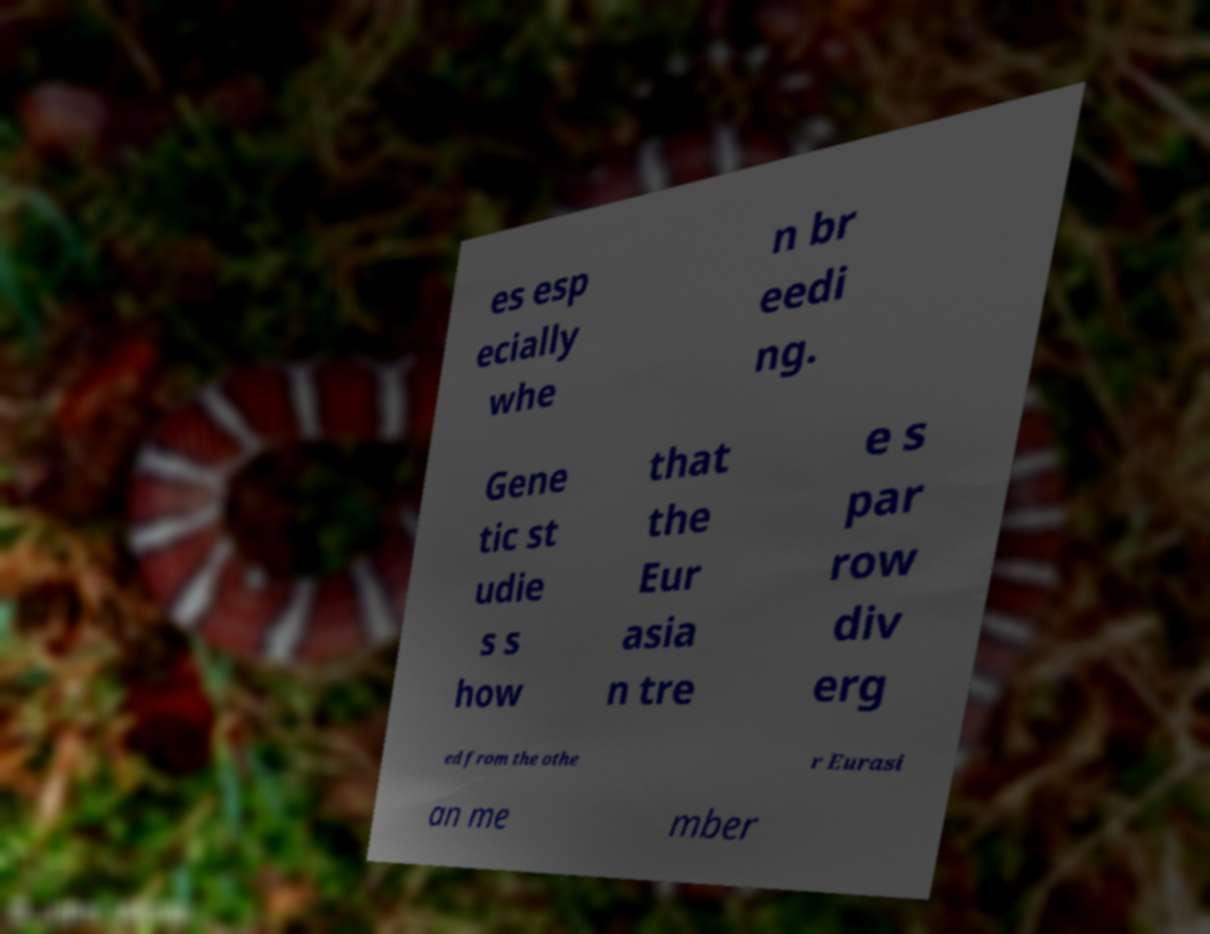Please read and relay the text visible in this image. What does it say? es esp ecially whe n br eedi ng. Gene tic st udie s s how that the Eur asia n tre e s par row div erg ed from the othe r Eurasi an me mber 